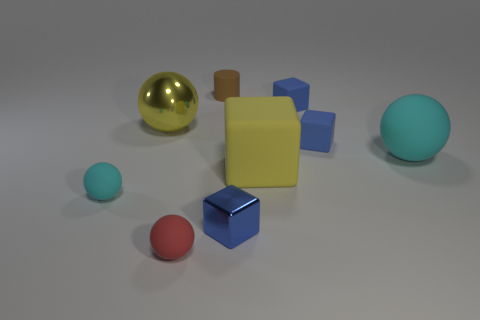Subtract all blue blocks. How many were subtracted if there are1blue blocks left? 2 Subtract all red spheres. How many blue cubes are left? 3 Add 1 yellow rubber blocks. How many objects exist? 10 Subtract all blocks. How many objects are left? 5 Subtract 2 blue blocks. How many objects are left? 7 Subtract all spheres. Subtract all tiny red rubber objects. How many objects are left? 4 Add 9 small brown matte things. How many small brown matte things are left? 10 Add 7 cyan matte cylinders. How many cyan matte cylinders exist? 7 